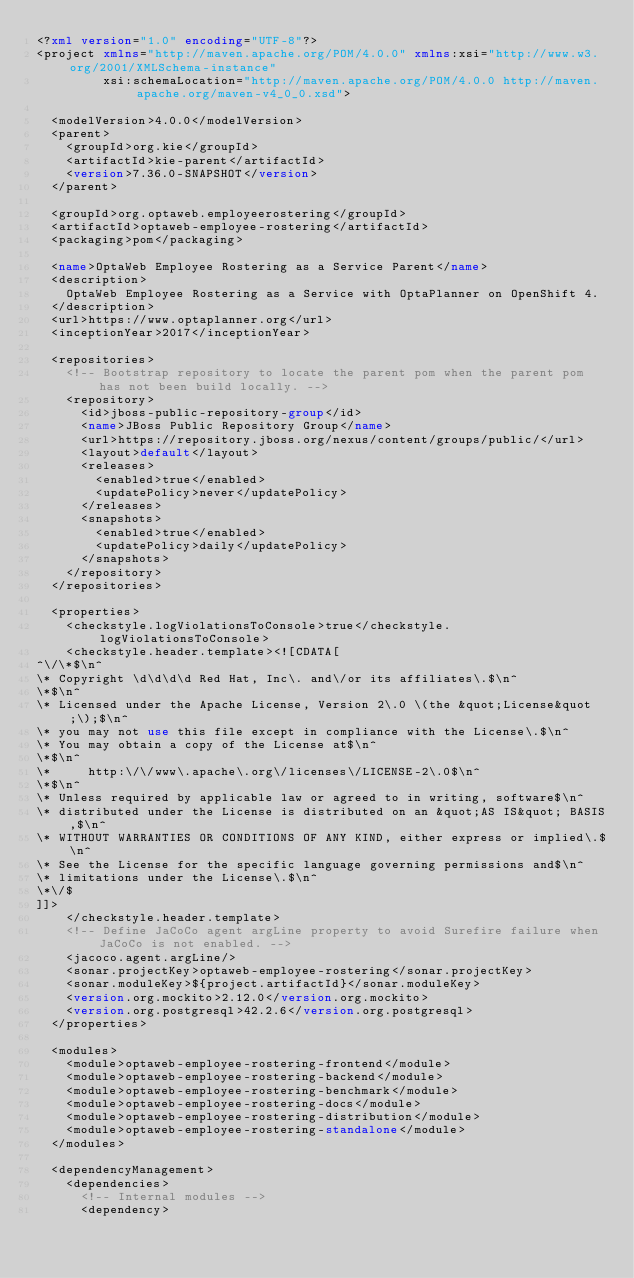Convert code to text. <code><loc_0><loc_0><loc_500><loc_500><_XML_><?xml version="1.0" encoding="UTF-8"?>
<project xmlns="http://maven.apache.org/POM/4.0.0" xmlns:xsi="http://www.w3.org/2001/XMLSchema-instance"
         xsi:schemaLocation="http://maven.apache.org/POM/4.0.0 http://maven.apache.org/maven-v4_0_0.xsd">

  <modelVersion>4.0.0</modelVersion>
  <parent>
    <groupId>org.kie</groupId>
    <artifactId>kie-parent</artifactId>
    <version>7.36.0-SNAPSHOT</version>
  </parent>

  <groupId>org.optaweb.employeerostering</groupId>
  <artifactId>optaweb-employee-rostering</artifactId>
  <packaging>pom</packaging>

  <name>OptaWeb Employee Rostering as a Service Parent</name>
  <description>
    OptaWeb Employee Rostering as a Service with OptaPlanner on OpenShift 4.
  </description>
  <url>https://www.optaplanner.org</url>
  <inceptionYear>2017</inceptionYear>

  <repositories>
    <!-- Bootstrap repository to locate the parent pom when the parent pom has not been build locally. -->
    <repository>
      <id>jboss-public-repository-group</id>
      <name>JBoss Public Repository Group</name>
      <url>https://repository.jboss.org/nexus/content/groups/public/</url>
      <layout>default</layout>
      <releases>
        <enabled>true</enabled>
        <updatePolicy>never</updatePolicy>
      </releases>
      <snapshots>
        <enabled>true</enabled>
        <updatePolicy>daily</updatePolicy>
      </snapshots>
    </repository>
  </repositories>

  <properties>
    <checkstyle.logViolationsToConsole>true</checkstyle.logViolationsToConsole>
    <checkstyle.header.template><![CDATA[
^\/\*$\n^
\* Copyright \d\d\d\d Red Hat, Inc\. and\/or its affiliates\.$\n^
\*$\n^
\* Licensed under the Apache License, Version 2\.0 \(the &quot;License&quot;\);$\n^
\* you may not use this file except in compliance with the License\.$\n^
\* You may obtain a copy of the License at$\n^
\*$\n^
\*     http:\/\/www\.apache\.org\/licenses\/LICENSE-2\.0$\n^
\*$\n^
\* Unless required by applicable law or agreed to in writing, software$\n^
\* distributed under the License is distributed on an &quot;AS IS&quot; BASIS,$\n^
\* WITHOUT WARRANTIES OR CONDITIONS OF ANY KIND, either express or implied\.$\n^
\* See the License for the specific language governing permissions and$\n^
\* limitations under the License\.$\n^
\*\/$
]]>
    </checkstyle.header.template>
    <!-- Define JaCoCo agent argLine property to avoid Surefire failure when JaCoCo is not enabled. -->
    <jacoco.agent.argLine/>
    <sonar.projectKey>optaweb-employee-rostering</sonar.projectKey>
    <sonar.moduleKey>${project.artifactId}</sonar.moduleKey>
    <version.org.mockito>2.12.0</version.org.mockito>
    <version.org.postgresql>42.2.6</version.org.postgresql>
  </properties>

  <modules>
    <module>optaweb-employee-rostering-frontend</module>
    <module>optaweb-employee-rostering-backend</module>
    <module>optaweb-employee-rostering-benchmark</module>
    <module>optaweb-employee-rostering-docs</module>
    <module>optaweb-employee-rostering-distribution</module>
    <module>optaweb-employee-rostering-standalone</module>
  </modules>

  <dependencyManagement>
    <dependencies>
      <!-- Internal modules -->
      <dependency></code> 